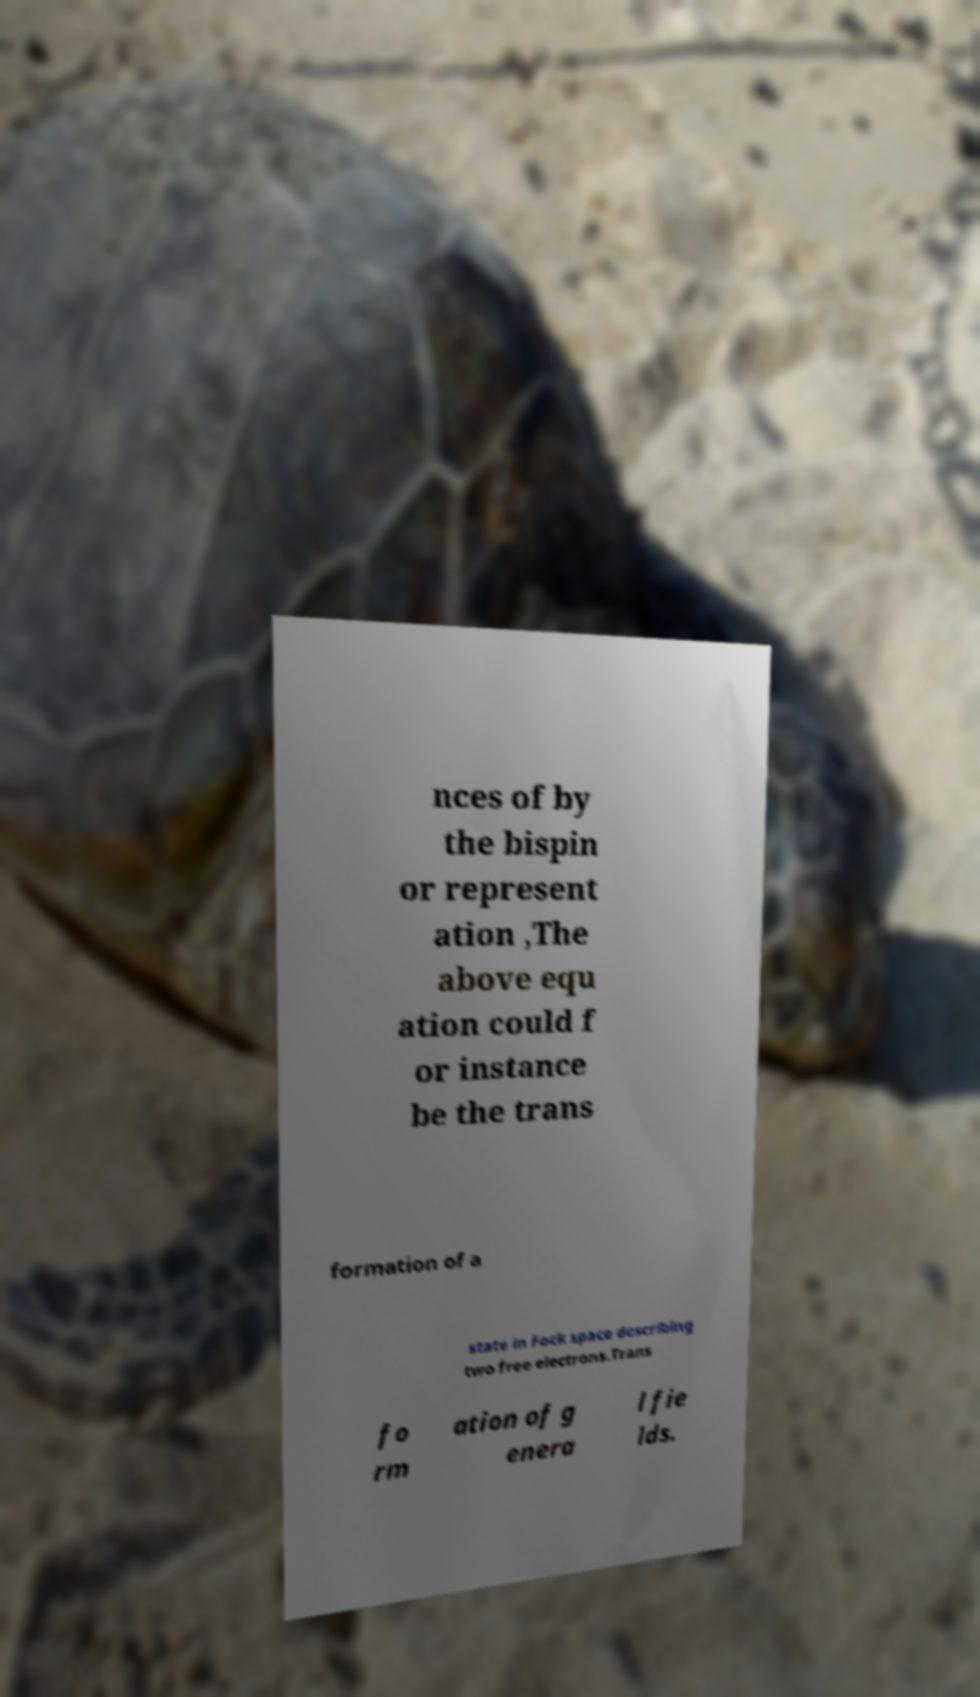Could you extract and type out the text from this image? nces of by the bispin or represent ation ,The above equ ation could f or instance be the trans formation of a state in Fock space describing two free electrons.Trans fo rm ation of g enera l fie lds. 